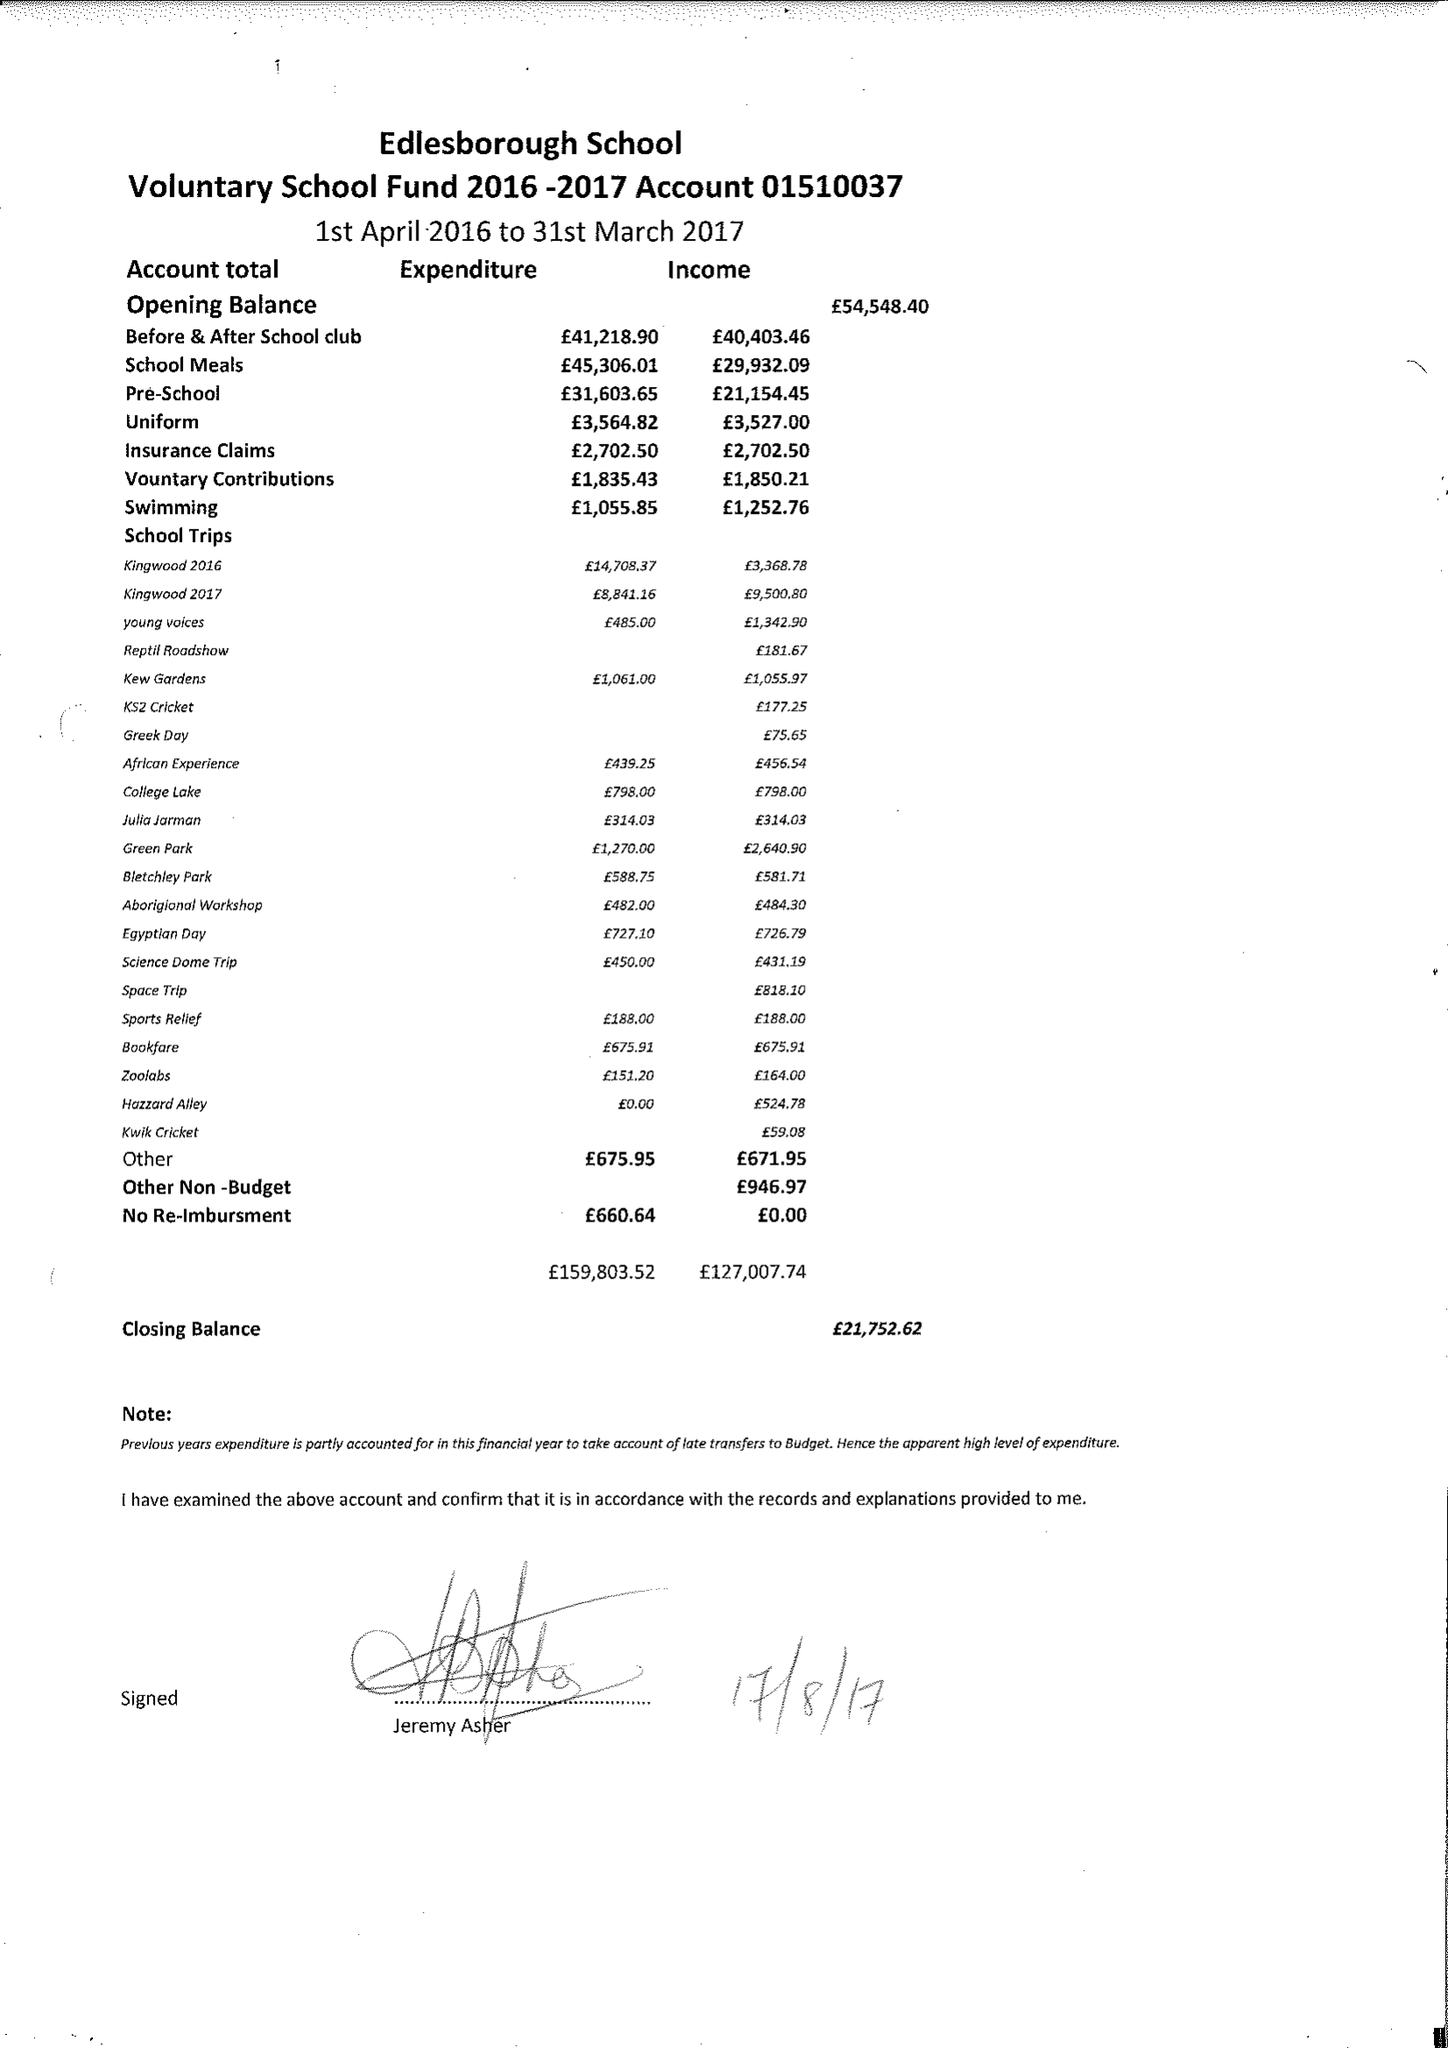What is the value for the charity_name?
Answer the question using a single word or phrase. Edlesborough School Fund 